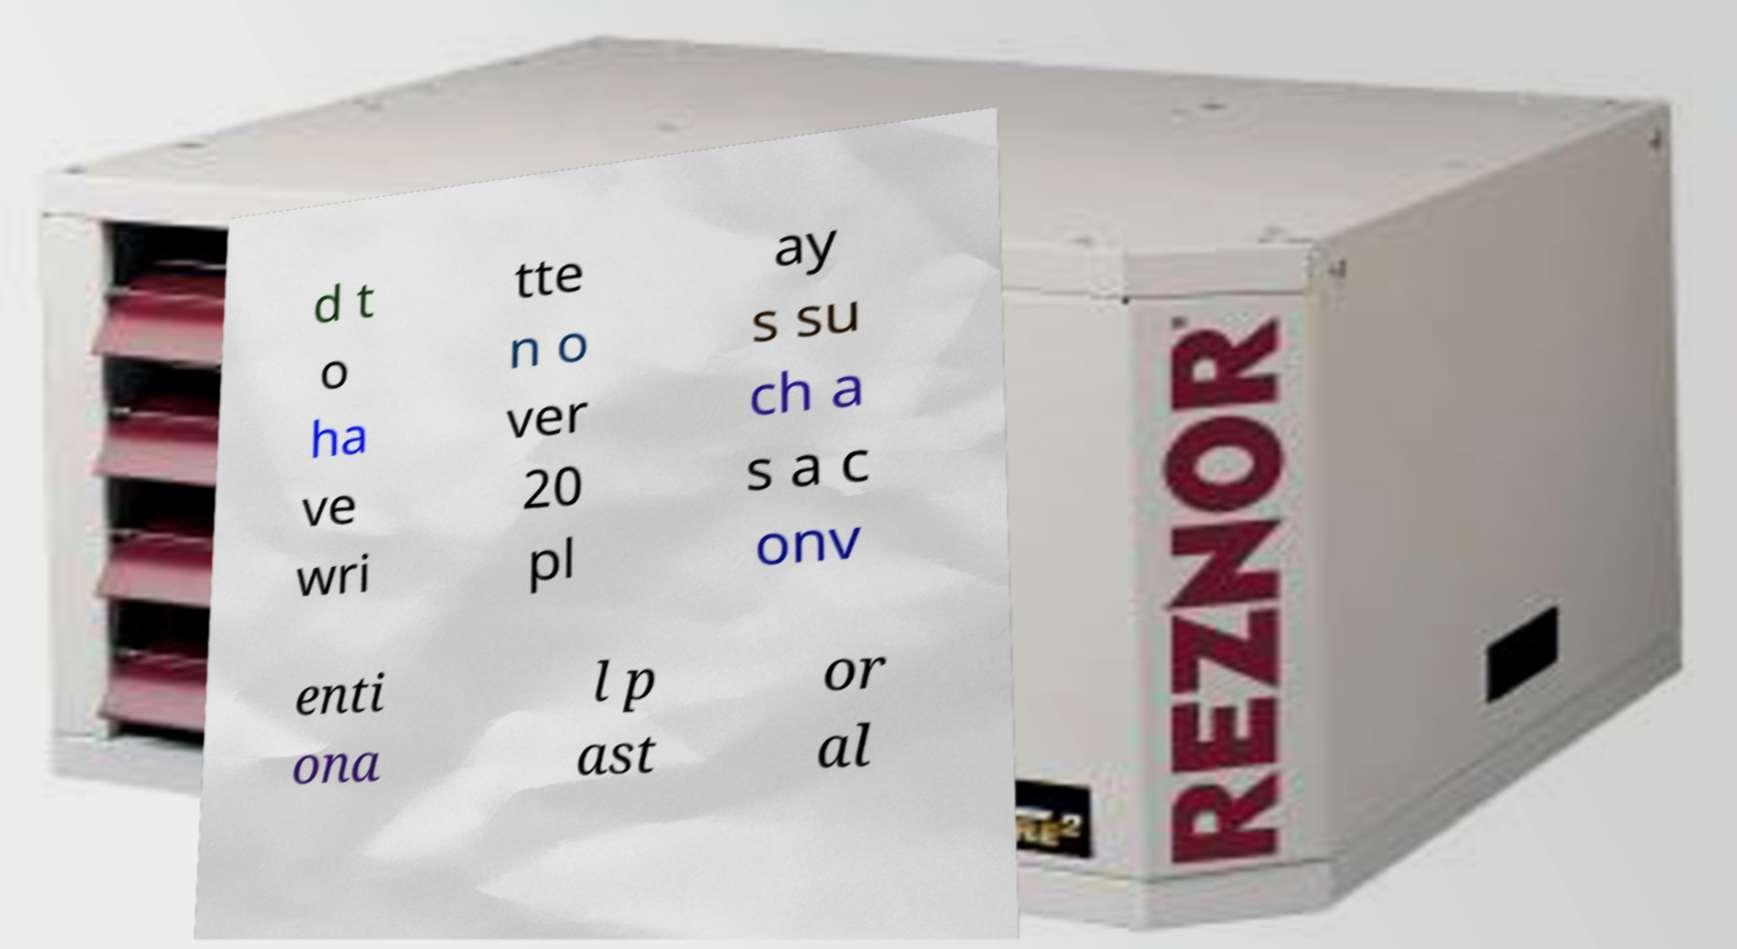Please identify and transcribe the text found in this image. d t o ha ve wri tte n o ver 20 pl ay s su ch a s a c onv enti ona l p ast or al 